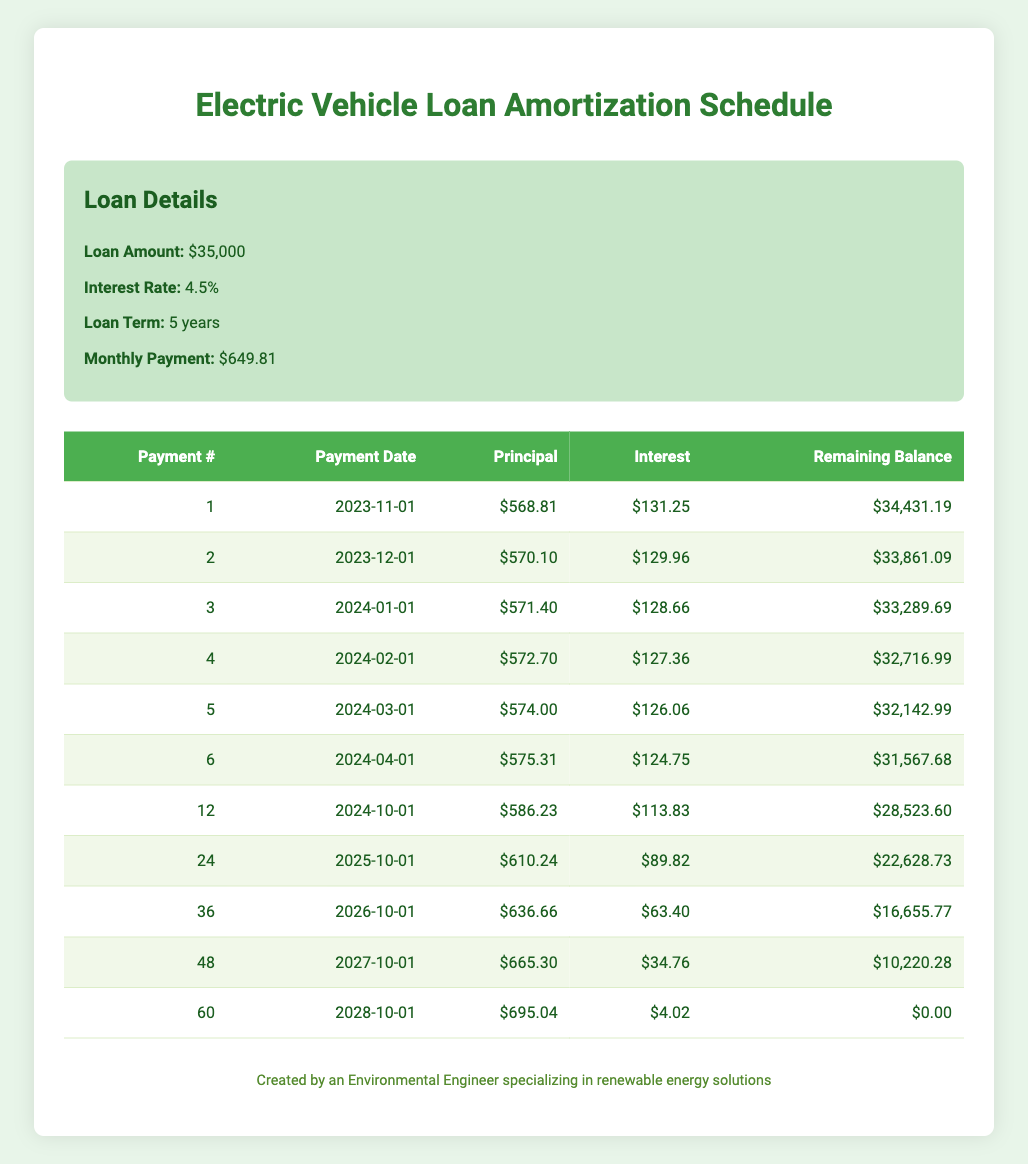What is the monthly payment for the electric vehicle loan? The monthly payment is listed directly under the loan details as $649.81.
Answer: $649.81 What is the principal payment for the first payment? The principal payment for the first payment is found in the first row of the payment schedule, which shows $568.81.
Answer: $568.81 Is the interest payment for the 5th payment greater than $120? The interest payment for the 5th payment is $126.06, which is greater than $120.
Answer: Yes What is the remaining balance after the second payment? The remaining balance after the second payment is provided in the payment schedule under the remaining balance column for the second payment, which is $33,861.09.
Answer: $33,861.09 What is the total principal payment made in the first six months? To find the total principal payment, we sum the principal payments for the first six payments: 568.81 + 570.10 + 571.40 + 572.70 + 574.00 + 575.31 = 3,032.32.
Answer: $3,032.32 What is the change in remaining balance from the first payment to the last payment? The remaining balance decreases from $34,431.19 (first payment) to $0.00 (last payment), so the change is 34,431.19 - 0.00 = 34,431.19.
Answer: $34,431.19 Is the monthly payment consistent throughout the loan term? The loan structure indicates that the monthly payment remains the same at $649.81 for each month of the loan term.
Answer: Yes What is the average interest payment in the first year? The interest payments for the first 12 months total $1,488.86 (sum of interest payments from the first year), and divided by 12 gives an average of 124.07.
Answer: $124.07 What is the principal payment number for the payment that results in a remaining balance of $10,220.28? The remaining balance of $10,220.28 occurs at the 48th payment according to the payment schedule.
Answer: 48 